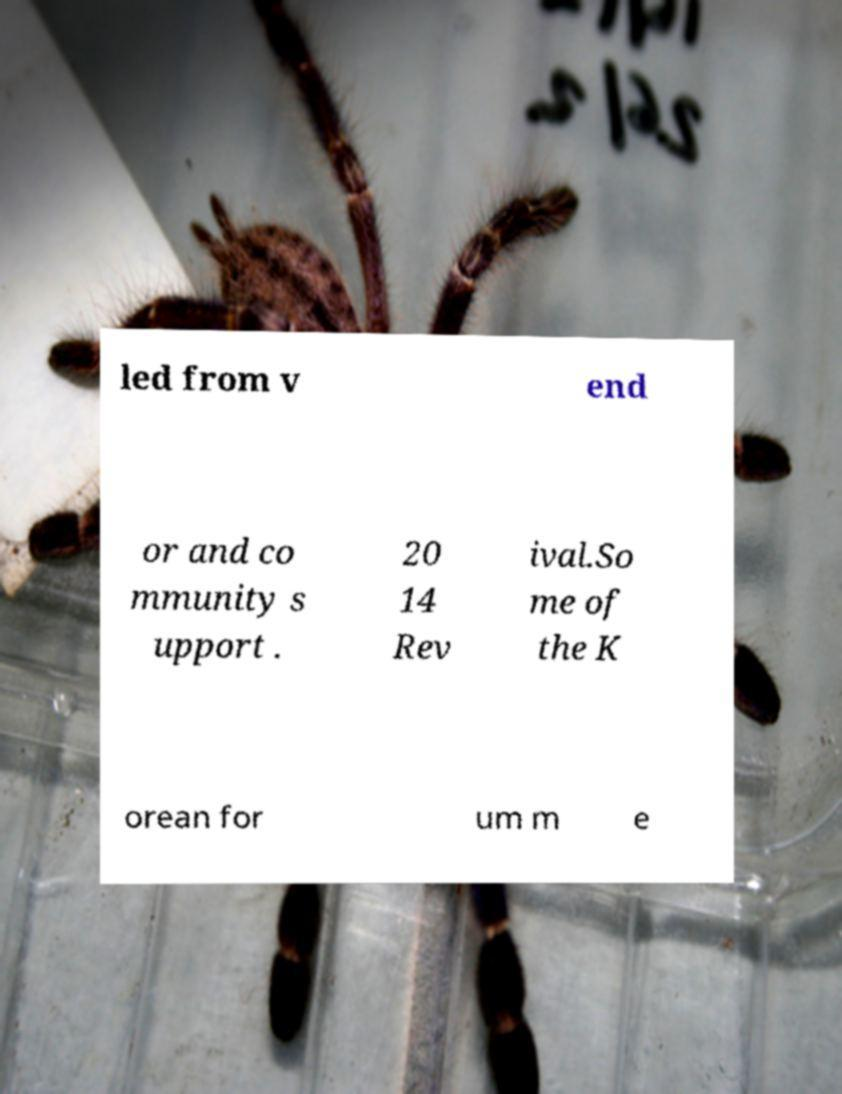Could you assist in decoding the text presented in this image and type it out clearly? led from v end or and co mmunity s upport . 20 14 Rev ival.So me of the K orean for um m e 